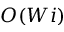<formula> <loc_0><loc_0><loc_500><loc_500>O ( W i )</formula> 